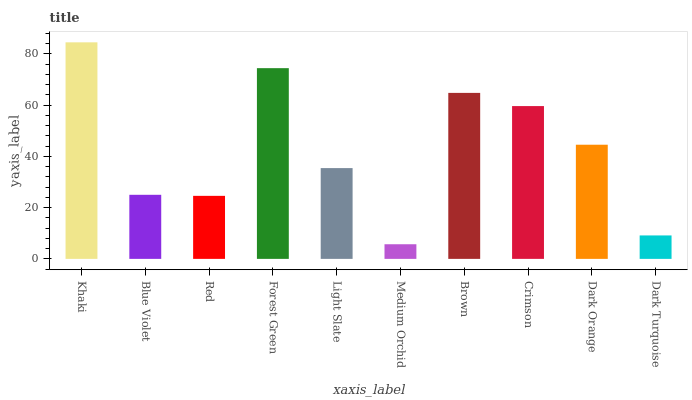Is Blue Violet the minimum?
Answer yes or no. No. Is Blue Violet the maximum?
Answer yes or no. No. Is Khaki greater than Blue Violet?
Answer yes or no. Yes. Is Blue Violet less than Khaki?
Answer yes or no. Yes. Is Blue Violet greater than Khaki?
Answer yes or no. No. Is Khaki less than Blue Violet?
Answer yes or no. No. Is Dark Orange the high median?
Answer yes or no. Yes. Is Light Slate the low median?
Answer yes or no. Yes. Is Brown the high median?
Answer yes or no. No. Is Forest Green the low median?
Answer yes or no. No. 